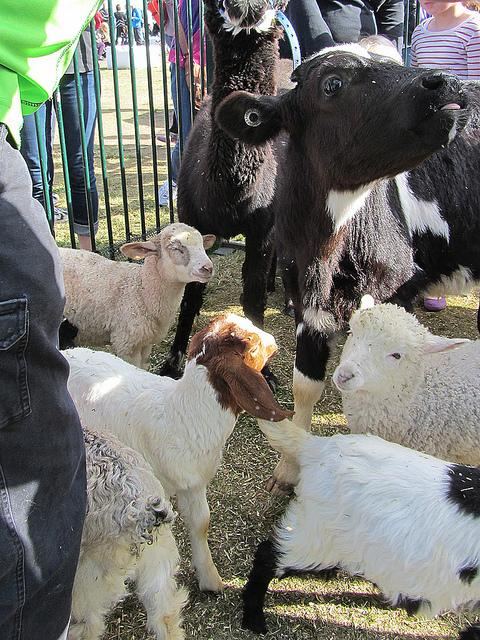What does the girl come to this venue for? petting 